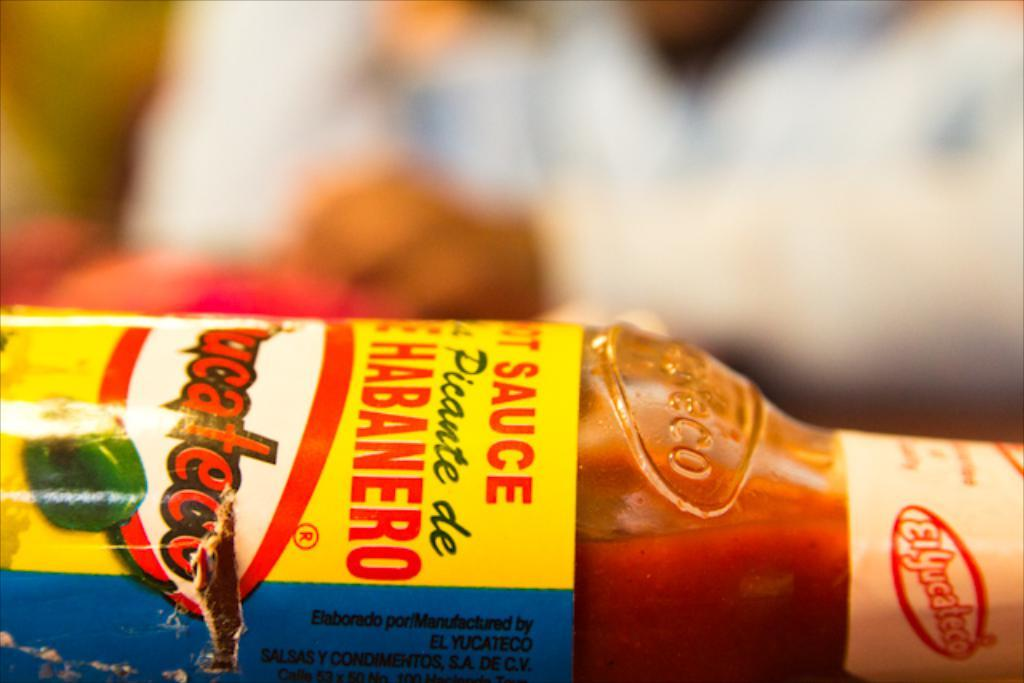<image>
Create a compact narrative representing the image presented. A bottle lying on its side contains hot sauce. 